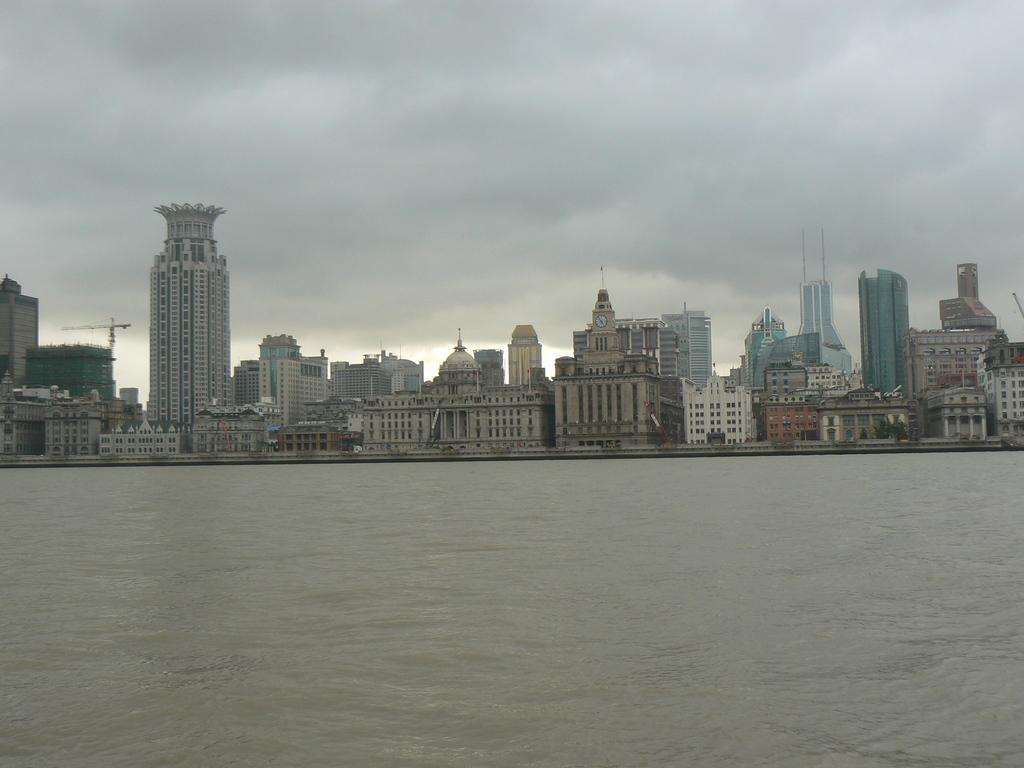Describe this image in one or two sentences. In this image, there are so many buildings, trees, crane and few objects. At the bottom of the image, we can see the water. In the background, there is the cloudy sky. 